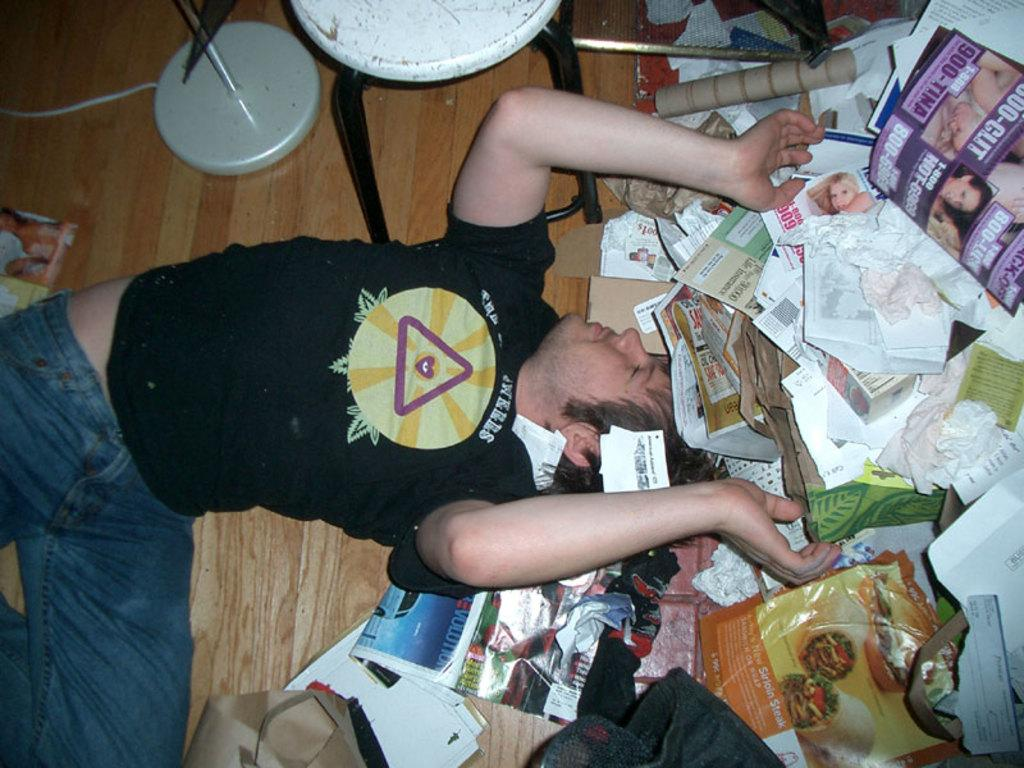What is the position of the person in the image? There is a person lying on the floor in the image. What can be seen on the papers in the image? There are papers with text in the image. What else is on the floor in the image? There are other objects on the floor in the image. What piece of furniture is near the person in the image? There is a stool near the person in the image. What caused the scene to change in the image? There is no indication of a scene change in the image; it is a static representation. 